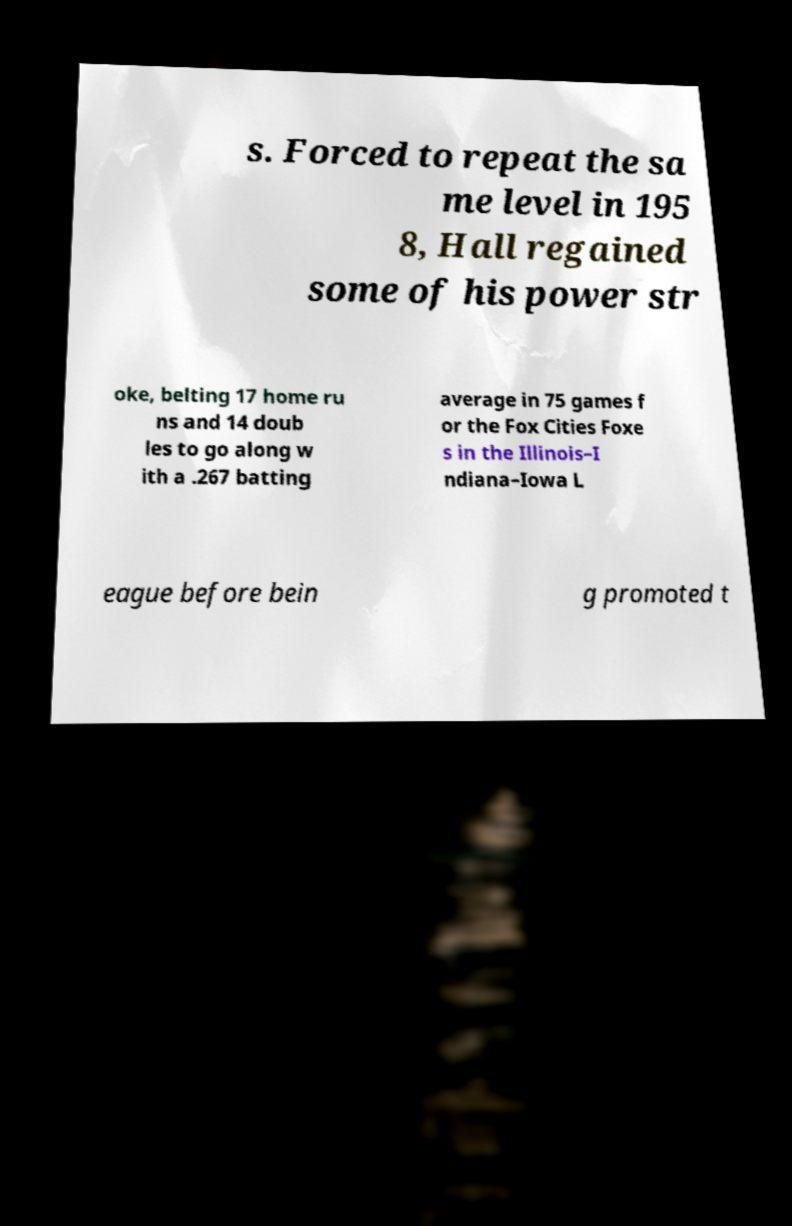Please read and relay the text visible in this image. What does it say? s. Forced to repeat the sa me level in 195 8, Hall regained some of his power str oke, belting 17 home ru ns and 14 doub les to go along w ith a .267 batting average in 75 games f or the Fox Cities Foxe s in the Illinois–I ndiana–Iowa L eague before bein g promoted t 